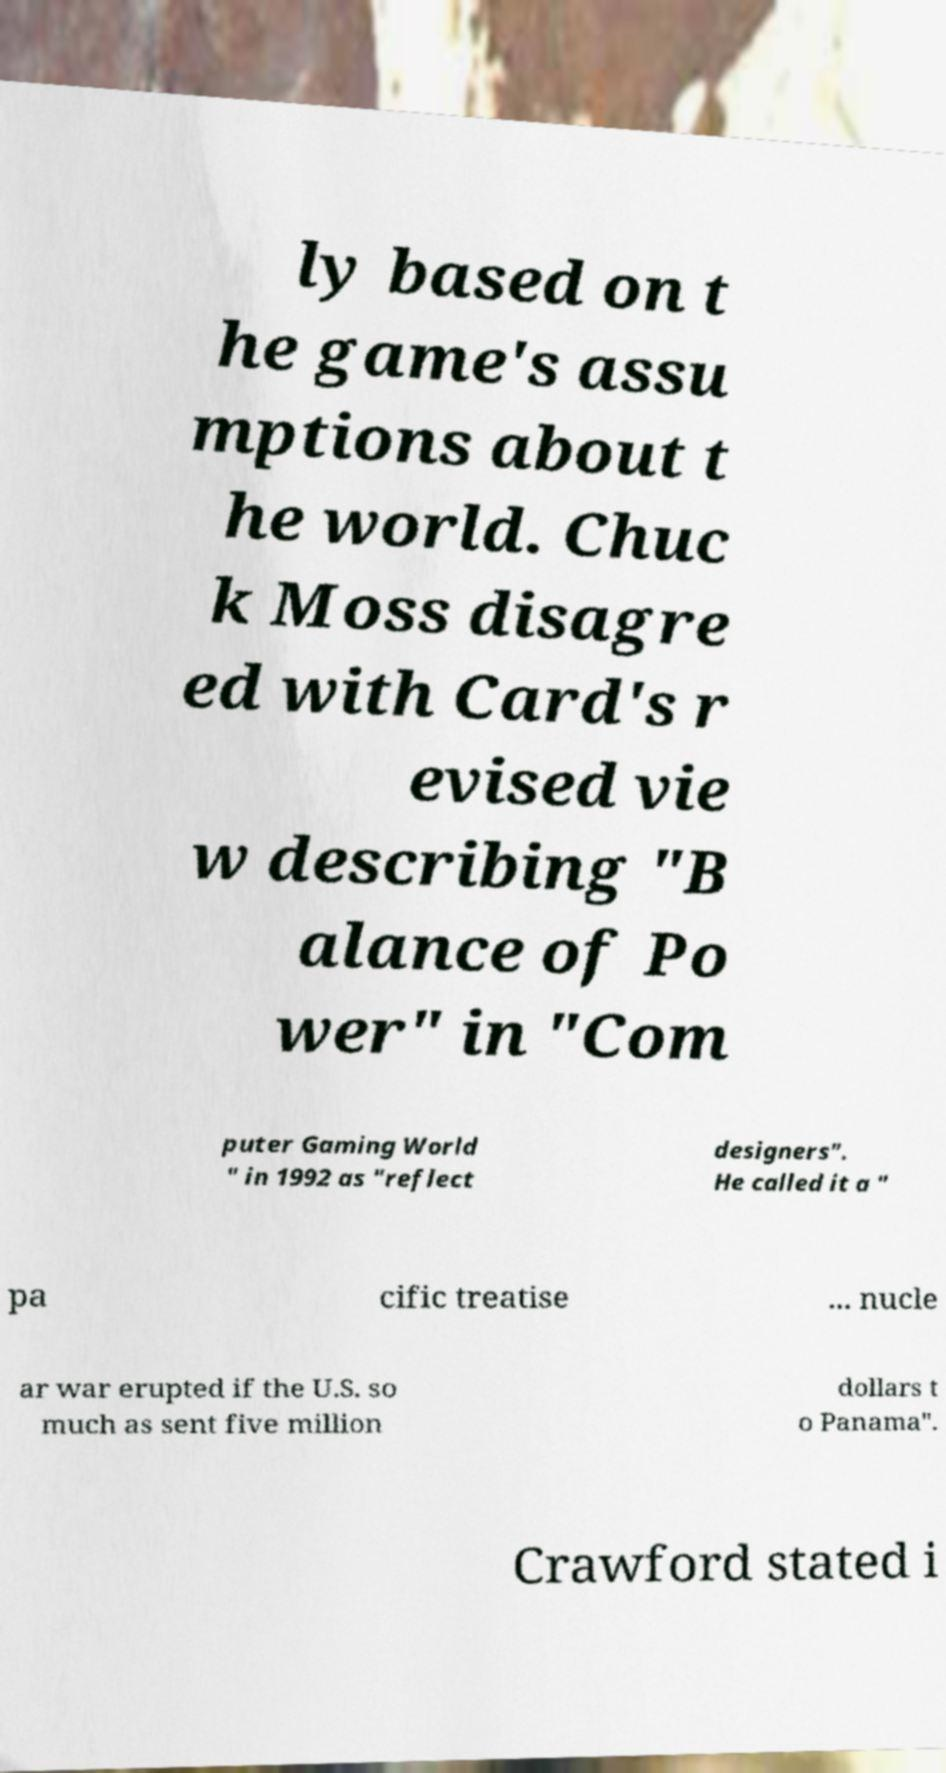Please identify and transcribe the text found in this image. ly based on t he game's assu mptions about t he world. Chuc k Moss disagre ed with Card's r evised vie w describing "B alance of Po wer" in "Com puter Gaming World " in 1992 as "reflect designers". He called it a " pa cific treatise ... nucle ar war erupted if the U.S. so much as sent five million dollars t o Panama". Crawford stated i 